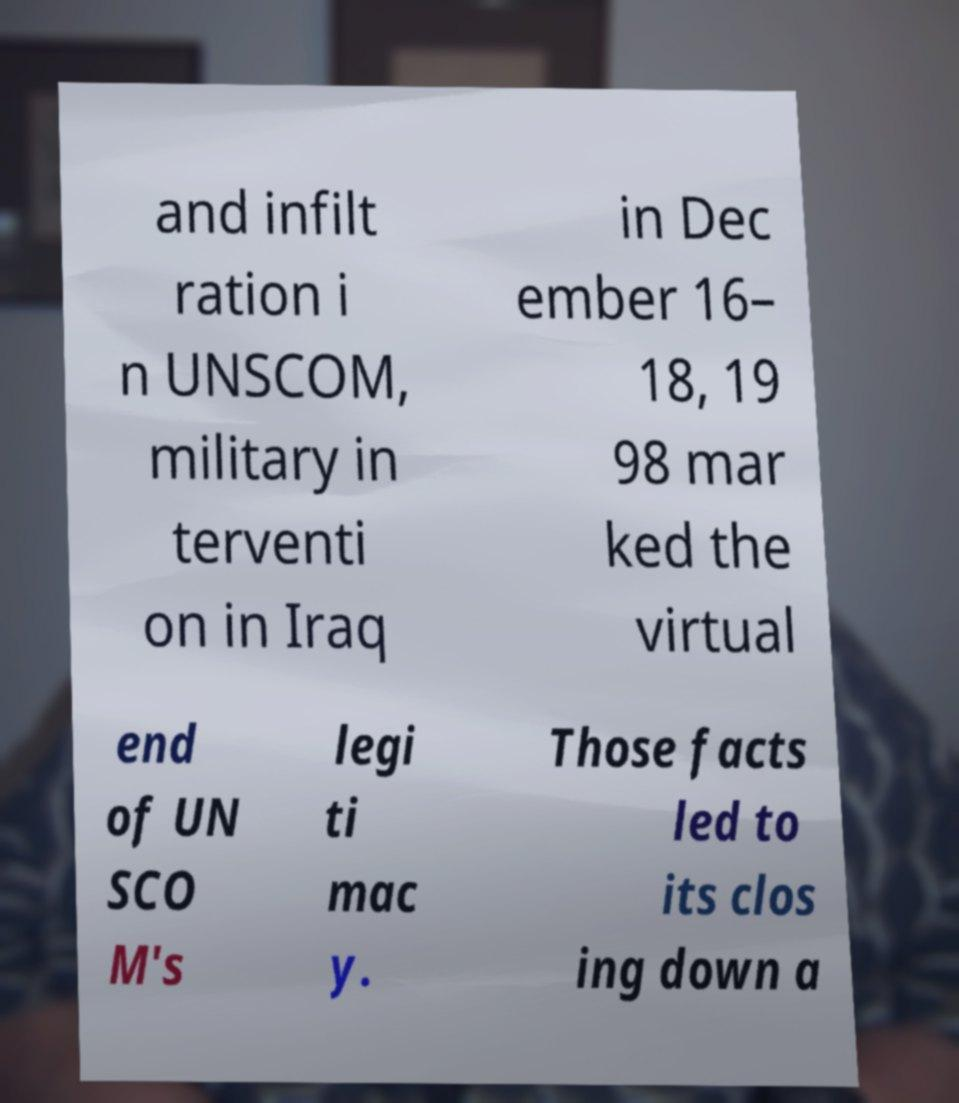Please read and relay the text visible in this image. What does it say? and infilt ration i n UNSCOM, military in terventi on in Iraq in Dec ember 16– 18, 19 98 mar ked the virtual end of UN SCO M's legi ti mac y. Those facts led to its clos ing down a 